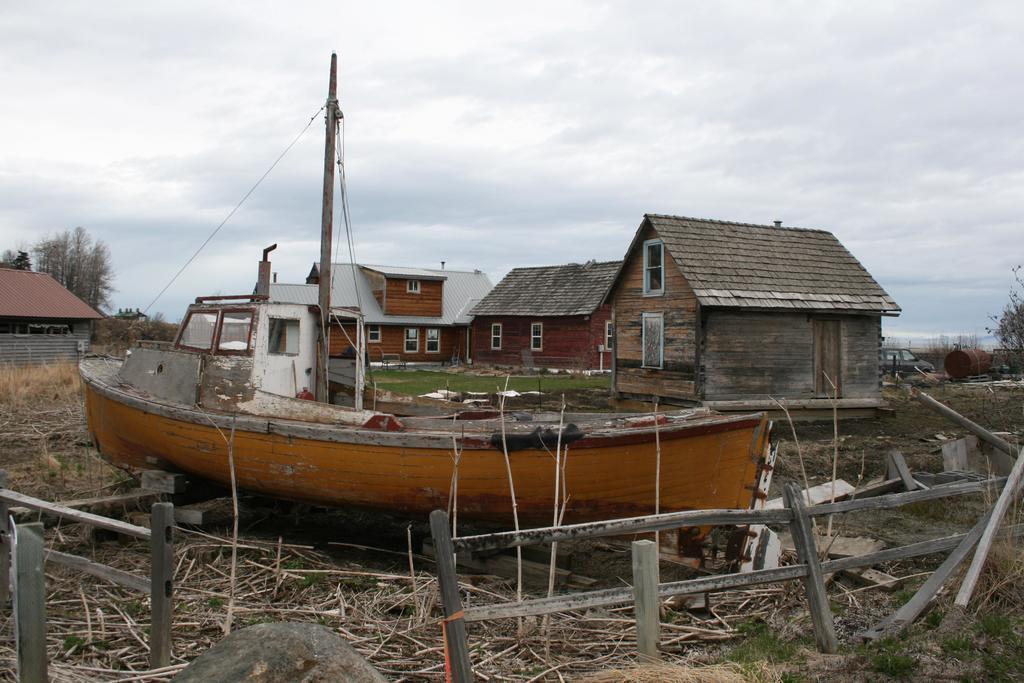Can you describe this image briefly? In this image there are sheds. At the bottom there is a fence and we can see twigs. There is a boat. In the background there are trees and sky. We can see a car. 